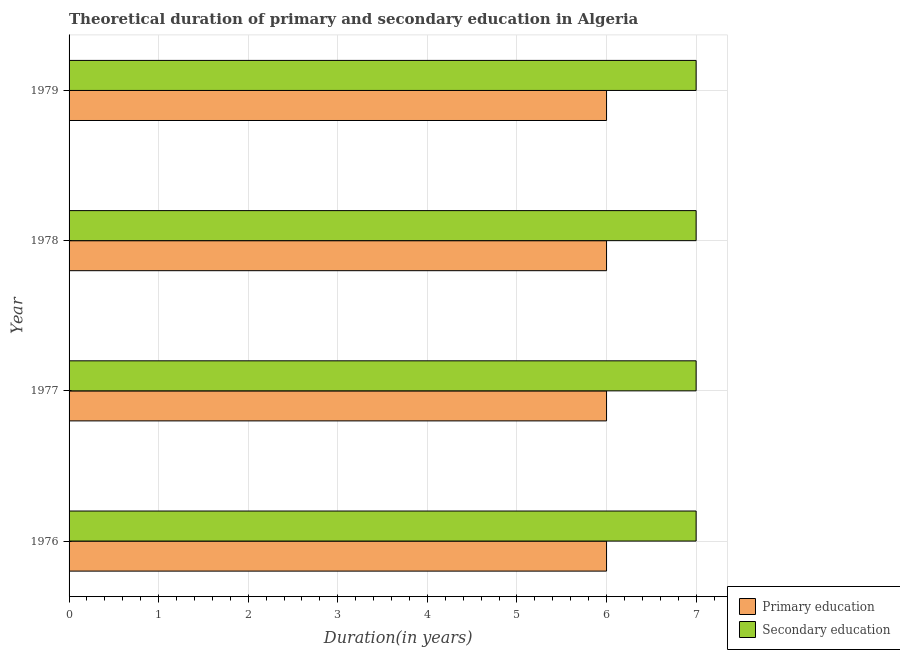How many groups of bars are there?
Make the answer very short. 4. Are the number of bars per tick equal to the number of legend labels?
Your answer should be very brief. Yes. Are the number of bars on each tick of the Y-axis equal?
Your response must be concise. Yes. How many bars are there on the 3rd tick from the top?
Your answer should be very brief. 2. What is the label of the 1st group of bars from the top?
Provide a short and direct response. 1979. In how many cases, is the number of bars for a given year not equal to the number of legend labels?
Your response must be concise. 0. What is the duration of secondary education in 1978?
Provide a succinct answer. 7. Across all years, what is the maximum duration of secondary education?
Your response must be concise. 7. In which year was the duration of secondary education maximum?
Your response must be concise. 1976. In which year was the duration of secondary education minimum?
Give a very brief answer. 1976. What is the total duration of primary education in the graph?
Make the answer very short. 24. What is the difference between the duration of secondary education in 1976 and the duration of primary education in 1978?
Ensure brevity in your answer.  1. In the year 1977, what is the difference between the duration of secondary education and duration of primary education?
Your answer should be compact. 1. Is the duration of primary education in 1976 less than that in 1977?
Keep it short and to the point. No. Is the difference between the duration of secondary education in 1977 and 1979 greater than the difference between the duration of primary education in 1977 and 1979?
Make the answer very short. No. What is the difference between the highest and the second highest duration of primary education?
Give a very brief answer. 0. Is the sum of the duration of secondary education in 1976 and 1979 greater than the maximum duration of primary education across all years?
Your answer should be compact. Yes. What does the 2nd bar from the top in 1978 represents?
Make the answer very short. Primary education. What does the 1st bar from the bottom in 1979 represents?
Your answer should be very brief. Primary education. Are all the bars in the graph horizontal?
Ensure brevity in your answer.  Yes. How many years are there in the graph?
Offer a terse response. 4. What is the difference between two consecutive major ticks on the X-axis?
Give a very brief answer. 1. Does the graph contain grids?
Give a very brief answer. Yes. Where does the legend appear in the graph?
Provide a succinct answer. Bottom right. How many legend labels are there?
Offer a terse response. 2. What is the title of the graph?
Provide a short and direct response. Theoretical duration of primary and secondary education in Algeria. What is the label or title of the X-axis?
Offer a very short reply. Duration(in years). What is the Duration(in years) in Secondary education in 1977?
Your response must be concise. 7. What is the Duration(in years) in Primary education in 1978?
Offer a very short reply. 6. What is the Duration(in years) in Secondary education in 1979?
Your answer should be compact. 7. Across all years, what is the maximum Duration(in years) of Primary education?
Your answer should be compact. 6. Across all years, what is the maximum Duration(in years) in Secondary education?
Your answer should be very brief. 7. Across all years, what is the minimum Duration(in years) of Primary education?
Make the answer very short. 6. Across all years, what is the minimum Duration(in years) of Secondary education?
Offer a very short reply. 7. What is the total Duration(in years) in Secondary education in the graph?
Your answer should be very brief. 28. What is the difference between the Duration(in years) in Primary education in 1976 and that in 1977?
Your response must be concise. 0. What is the difference between the Duration(in years) of Secondary education in 1976 and that in 1978?
Your answer should be compact. 0. What is the difference between the Duration(in years) of Primary education in 1976 and that in 1979?
Provide a short and direct response. 0. What is the difference between the Duration(in years) of Primary education in 1977 and that in 1979?
Your answer should be compact. 0. What is the difference between the Duration(in years) in Secondary education in 1977 and that in 1979?
Your response must be concise. 0. What is the difference between the Duration(in years) of Primary education in 1978 and that in 1979?
Ensure brevity in your answer.  0. What is the difference between the Duration(in years) in Primary education in 1976 and the Duration(in years) in Secondary education in 1977?
Provide a succinct answer. -1. What is the difference between the Duration(in years) in Primary education in 1976 and the Duration(in years) in Secondary education in 1978?
Your answer should be very brief. -1. What is the difference between the Duration(in years) of Primary education in 1976 and the Duration(in years) of Secondary education in 1979?
Give a very brief answer. -1. What is the difference between the Duration(in years) in Primary education in 1977 and the Duration(in years) in Secondary education in 1978?
Your answer should be very brief. -1. What is the difference between the Duration(in years) of Primary education in 1978 and the Duration(in years) of Secondary education in 1979?
Your response must be concise. -1. What is the average Duration(in years) in Primary education per year?
Provide a succinct answer. 6. What is the ratio of the Duration(in years) in Primary education in 1976 to that in 1977?
Ensure brevity in your answer.  1. What is the ratio of the Duration(in years) of Secondary education in 1976 to that in 1977?
Your answer should be compact. 1. What is the ratio of the Duration(in years) of Secondary education in 1976 to that in 1978?
Give a very brief answer. 1. What is the ratio of the Duration(in years) in Primary education in 1976 to that in 1979?
Provide a succinct answer. 1. What is the ratio of the Duration(in years) in Primary education in 1977 to that in 1978?
Offer a very short reply. 1. What is the ratio of the Duration(in years) of Secondary education in 1977 to that in 1978?
Provide a short and direct response. 1. What is the ratio of the Duration(in years) in Secondary education in 1977 to that in 1979?
Your response must be concise. 1. What is the ratio of the Duration(in years) in Primary education in 1978 to that in 1979?
Your answer should be very brief. 1. What is the ratio of the Duration(in years) of Secondary education in 1978 to that in 1979?
Your answer should be very brief. 1. What is the difference between the highest and the second highest Duration(in years) in Primary education?
Provide a succinct answer. 0. What is the difference between the highest and the lowest Duration(in years) of Primary education?
Make the answer very short. 0. What is the difference between the highest and the lowest Duration(in years) in Secondary education?
Give a very brief answer. 0. 